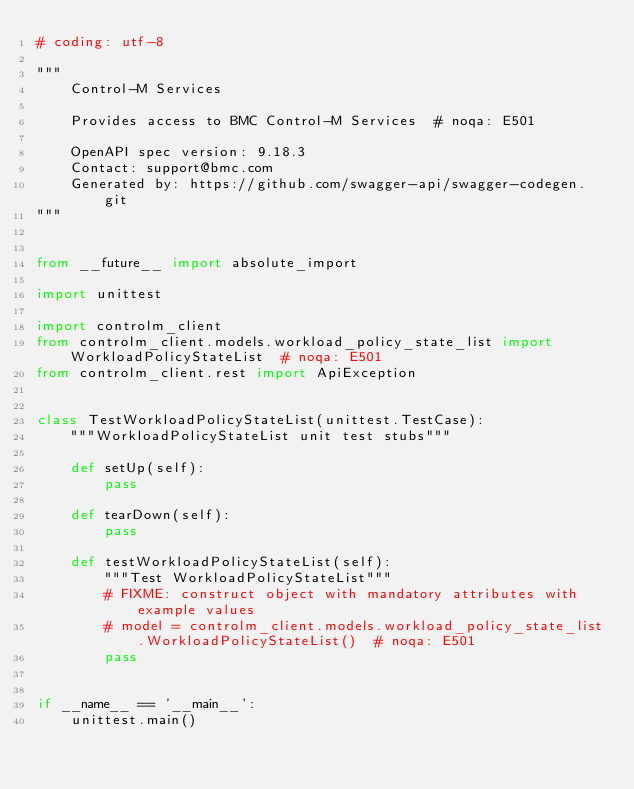Convert code to text. <code><loc_0><loc_0><loc_500><loc_500><_Python_># coding: utf-8

"""
    Control-M Services

    Provides access to BMC Control-M Services  # noqa: E501

    OpenAPI spec version: 9.18.3
    Contact: support@bmc.com
    Generated by: https://github.com/swagger-api/swagger-codegen.git
"""


from __future__ import absolute_import

import unittest

import controlm_client
from controlm_client.models.workload_policy_state_list import WorkloadPolicyStateList  # noqa: E501
from controlm_client.rest import ApiException


class TestWorkloadPolicyStateList(unittest.TestCase):
    """WorkloadPolicyStateList unit test stubs"""

    def setUp(self):
        pass

    def tearDown(self):
        pass

    def testWorkloadPolicyStateList(self):
        """Test WorkloadPolicyStateList"""
        # FIXME: construct object with mandatory attributes with example values
        # model = controlm_client.models.workload_policy_state_list.WorkloadPolicyStateList()  # noqa: E501
        pass


if __name__ == '__main__':
    unittest.main()
</code> 